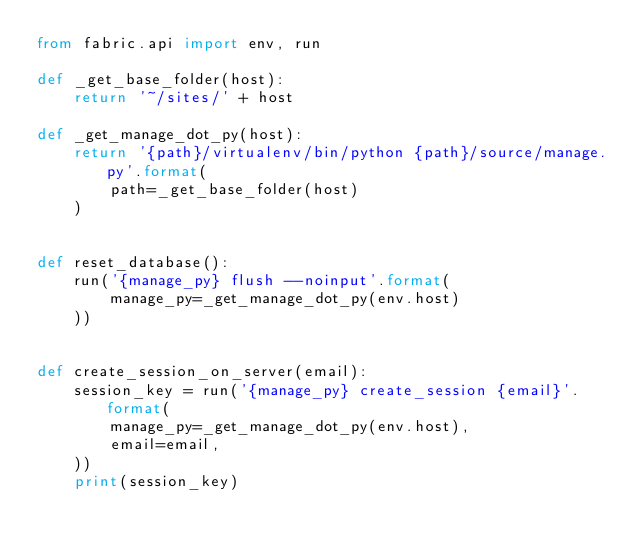Convert code to text. <code><loc_0><loc_0><loc_500><loc_500><_Python_>from fabric.api import env, run

def _get_base_folder(host):
    return '~/sites/' + host

def _get_manage_dot_py(host):
    return '{path}/virtualenv/bin/python {path}/source/manage.py'.format(
        path=_get_base_folder(host)
    )


def reset_database():
    run('{manage_py} flush --noinput'.format(
        manage_py=_get_manage_dot_py(env.host)
    ))


def create_session_on_server(email):
    session_key = run('{manage_py} create_session {email}'.format(
        manage_py=_get_manage_dot_py(env.host),
        email=email,
    ))
    print(session_key)
</code> 